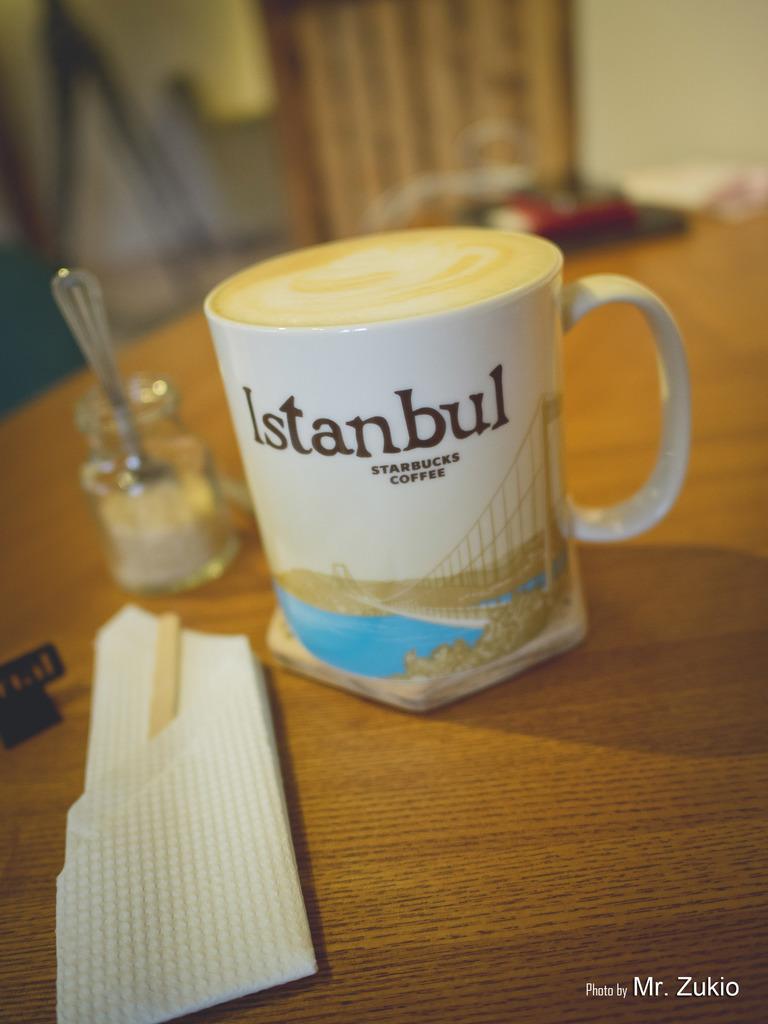Which country is on the mug?
Offer a terse response. Istanbul. 